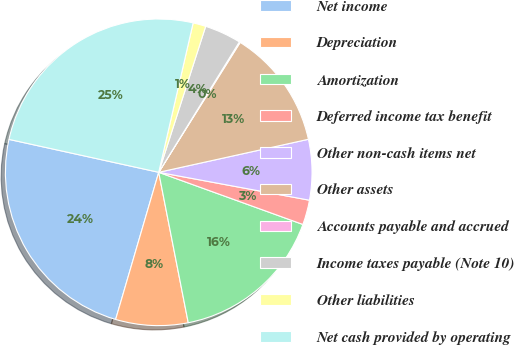Convert chart to OTSL. <chart><loc_0><loc_0><loc_500><loc_500><pie_chart><fcel>Net income<fcel>Depreciation<fcel>Amortization<fcel>Deferred income tax benefit<fcel>Other non-cash items net<fcel>Other assets<fcel>Accounts payable and accrued<fcel>Income taxes payable (Note 10)<fcel>Other liabilities<fcel>Net cash provided by operating<nl><fcel>23.91%<fcel>7.62%<fcel>16.39%<fcel>2.61%<fcel>6.37%<fcel>12.63%<fcel>0.1%<fcel>3.86%<fcel>1.35%<fcel>25.16%<nl></chart> 